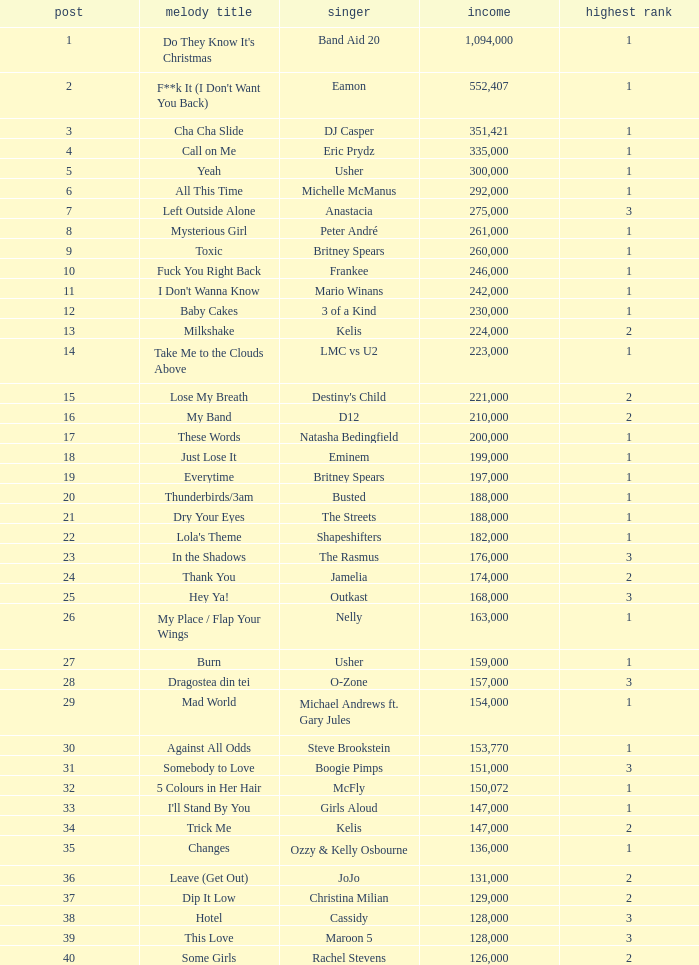Can you parse all the data within this table? {'header': ['post', 'melody title', 'singer', 'income', 'highest rank'], 'rows': [['1', "Do They Know It's Christmas", 'Band Aid 20', '1,094,000', '1'], ['2', "F**k It (I Don't Want You Back)", 'Eamon', '552,407', '1'], ['3', 'Cha Cha Slide', 'DJ Casper', '351,421', '1'], ['4', 'Call on Me', 'Eric Prydz', '335,000', '1'], ['5', 'Yeah', 'Usher', '300,000', '1'], ['6', 'All This Time', 'Michelle McManus', '292,000', '1'], ['7', 'Left Outside Alone', 'Anastacia', '275,000', '3'], ['8', 'Mysterious Girl', 'Peter André', '261,000', '1'], ['9', 'Toxic', 'Britney Spears', '260,000', '1'], ['10', 'Fuck You Right Back', 'Frankee', '246,000', '1'], ['11', "I Don't Wanna Know", 'Mario Winans', '242,000', '1'], ['12', 'Baby Cakes', '3 of a Kind', '230,000', '1'], ['13', 'Milkshake', 'Kelis', '224,000', '2'], ['14', 'Take Me to the Clouds Above', 'LMC vs U2', '223,000', '1'], ['15', 'Lose My Breath', "Destiny's Child", '221,000', '2'], ['16', 'My Band', 'D12', '210,000', '2'], ['17', 'These Words', 'Natasha Bedingfield', '200,000', '1'], ['18', 'Just Lose It', 'Eminem', '199,000', '1'], ['19', 'Everytime', 'Britney Spears', '197,000', '1'], ['20', 'Thunderbirds/3am', 'Busted', '188,000', '1'], ['21', 'Dry Your Eyes', 'The Streets', '188,000', '1'], ['22', "Lola's Theme", 'Shapeshifters', '182,000', '1'], ['23', 'In the Shadows', 'The Rasmus', '176,000', '3'], ['24', 'Thank You', 'Jamelia', '174,000', '2'], ['25', 'Hey Ya!', 'Outkast', '168,000', '3'], ['26', 'My Place / Flap Your Wings', 'Nelly', '163,000', '1'], ['27', 'Burn', 'Usher', '159,000', '1'], ['28', 'Dragostea din tei', 'O-Zone', '157,000', '3'], ['29', 'Mad World', 'Michael Andrews ft. Gary Jules', '154,000', '1'], ['30', 'Against All Odds', 'Steve Brookstein', '153,770', '1'], ['31', 'Somebody to Love', 'Boogie Pimps', '151,000', '3'], ['32', '5 Colours in Her Hair', 'McFly', '150,072', '1'], ['33', "I'll Stand By You", 'Girls Aloud', '147,000', '1'], ['34', 'Trick Me', 'Kelis', '147,000', '2'], ['35', 'Changes', 'Ozzy & Kelly Osbourne', '136,000', '1'], ['36', 'Leave (Get Out)', 'JoJo', '131,000', '2'], ['37', 'Dip It Low', 'Christina Milian', '129,000', '2'], ['38', 'Hotel', 'Cassidy', '128,000', '3'], ['39', 'This Love', 'Maroon 5', '128,000', '3'], ['40', 'Some Girls', 'Rachel Stevens', '126,000', '2']]} What is the most sales by a song with a position higher than 3? None. 